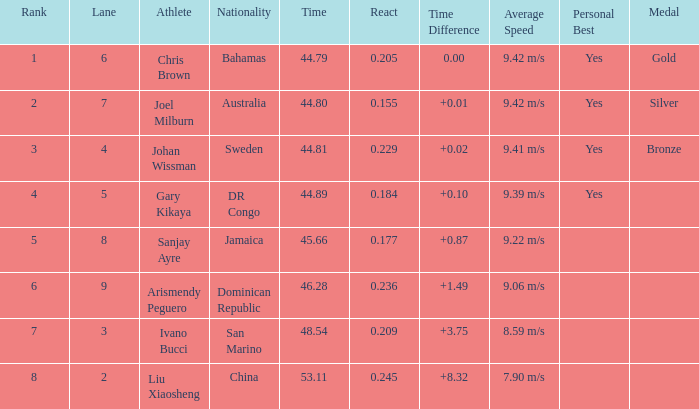What Lane has a 0.209 React entered with a Rank entry that is larger than 6? 2.0. 